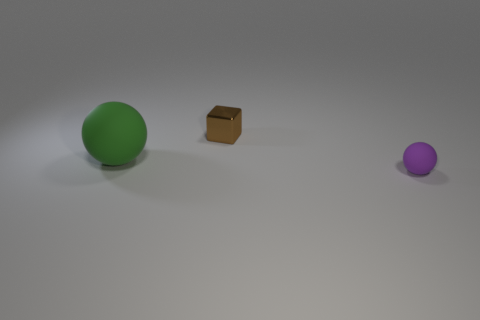Are there any other things that are made of the same material as the block?
Your response must be concise. No. Are there the same number of small blocks left of the green ball and small gray shiny blocks?
Make the answer very short. Yes. What is the shape of the other object that is made of the same material as the green thing?
Your answer should be very brief. Sphere. Are there any large spheres that have the same color as the big rubber thing?
Ensure brevity in your answer.  No. What number of rubber objects are purple spheres or blue balls?
Keep it short and to the point. 1. How many rubber things are to the left of the small object to the right of the shiny cube?
Your answer should be compact. 1. What number of other purple objects are made of the same material as the small purple thing?
Your answer should be compact. 0. What number of large objects are either cyan shiny things or purple rubber balls?
Provide a short and direct response. 0. What shape is the object that is to the right of the green object and in front of the brown shiny block?
Your answer should be very brief. Sphere. Do the purple sphere and the big sphere have the same material?
Your answer should be compact. Yes. 